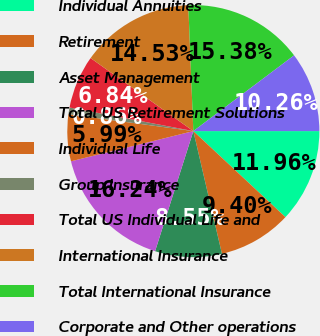<chart> <loc_0><loc_0><loc_500><loc_500><pie_chart><fcel>Individual Annuities<fcel>Retirement<fcel>Asset Management<fcel>Total US Retirement Solutions<fcel>Individual Life<fcel>Group Insurance<fcel>Total US Individual Life and<fcel>International Insurance<fcel>Total International Insurance<fcel>Corporate and Other operations<nl><fcel>11.96%<fcel>9.4%<fcel>8.55%<fcel>16.24%<fcel>5.99%<fcel>0.86%<fcel>6.84%<fcel>14.53%<fcel>15.38%<fcel>10.26%<nl></chart> 